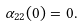<formula> <loc_0><loc_0><loc_500><loc_500>\alpha _ { 2 2 } ( 0 ) = 0 .</formula> 